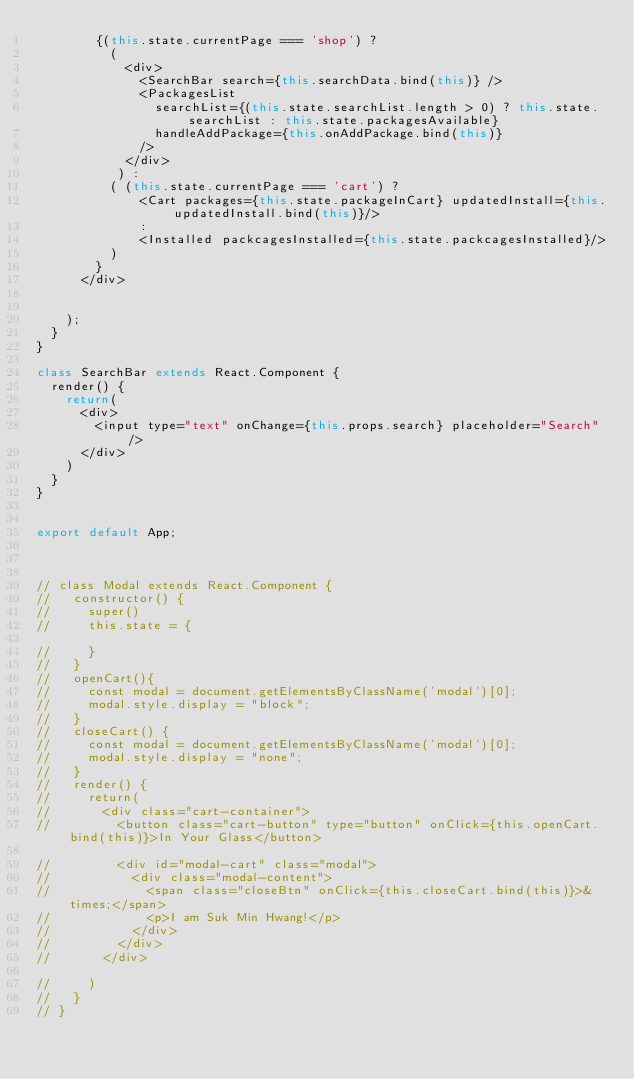<code> <loc_0><loc_0><loc_500><loc_500><_JavaScript_>        {(this.state.currentPage === 'shop') ?
          (
            <div>
              <SearchBar search={this.searchData.bind(this)} />
              <PackagesList 
                searchList={(this.state.searchList.length > 0) ? this.state.searchList : this.state.packagesAvailable} 
                handleAddPackage={this.onAddPackage.bind(this)}
              />
            </div>
           ) : 
          ( (this.state.currentPage === 'cart') ?
              <Cart packages={this.state.packageInCart} updatedInstall={this.updatedInstall.bind(this)}/>
              :
              <Installed packcagesInstalled={this.state.packcagesInstalled}/>
          )
        }
      </div>


    );
  }
}

class SearchBar extends React.Component {
  render() {
    return(
      <div>
        <input type="text" onChange={this.props.search} placeholder="Search"/>
      </div>
    )
  }
}


export default App;



// class Modal extends React.Component {
//   constructor() {
//     super()
//     this.state = {

//     }
//   }
//   openCart(){
//     const modal = document.getElementsByClassName('modal')[0];
//     modal.style.display = "block";
//   }
//   closeCart() {
//     const modal = document.getElementsByClassName('modal')[0];
//     modal.style.display = "none";
//   }
//   render() {
//     return(
//       <div class="cart-container">
//         <button class="cart-button" type="button" onClick={this.openCart.bind(this)}>In Your Glass</button>

//         <div id="modal-cart" class="modal">
//           <div class="modal-content">
//             <span class="closeBtn" onClick={this.closeCart.bind(this)}>&times;</span>
//             <p>I am Suk Min Hwang!</p>
//           </div>
//         </div>
//       </div>

//     )
//   }
// }</code> 